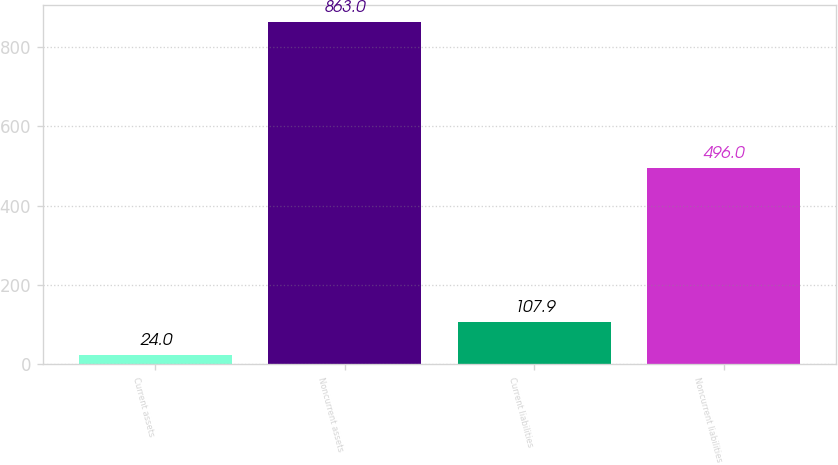<chart> <loc_0><loc_0><loc_500><loc_500><bar_chart><fcel>Current assets<fcel>Noncurrent assets<fcel>Current liabilities<fcel>Noncurrent liabilities<nl><fcel>24<fcel>863<fcel>107.9<fcel>496<nl></chart> 